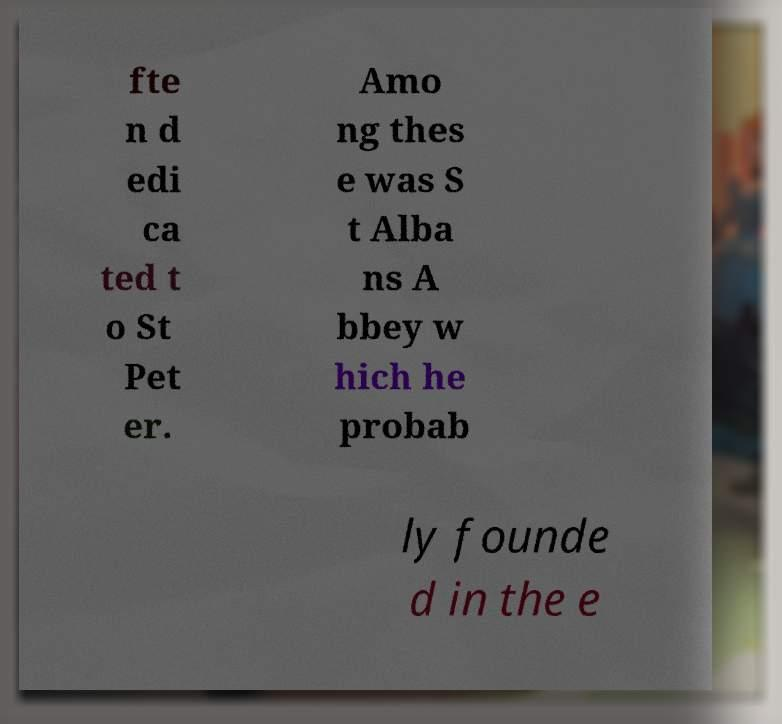Please identify and transcribe the text found in this image. fte n d edi ca ted t o St Pet er. Amo ng thes e was S t Alba ns A bbey w hich he probab ly founde d in the e 